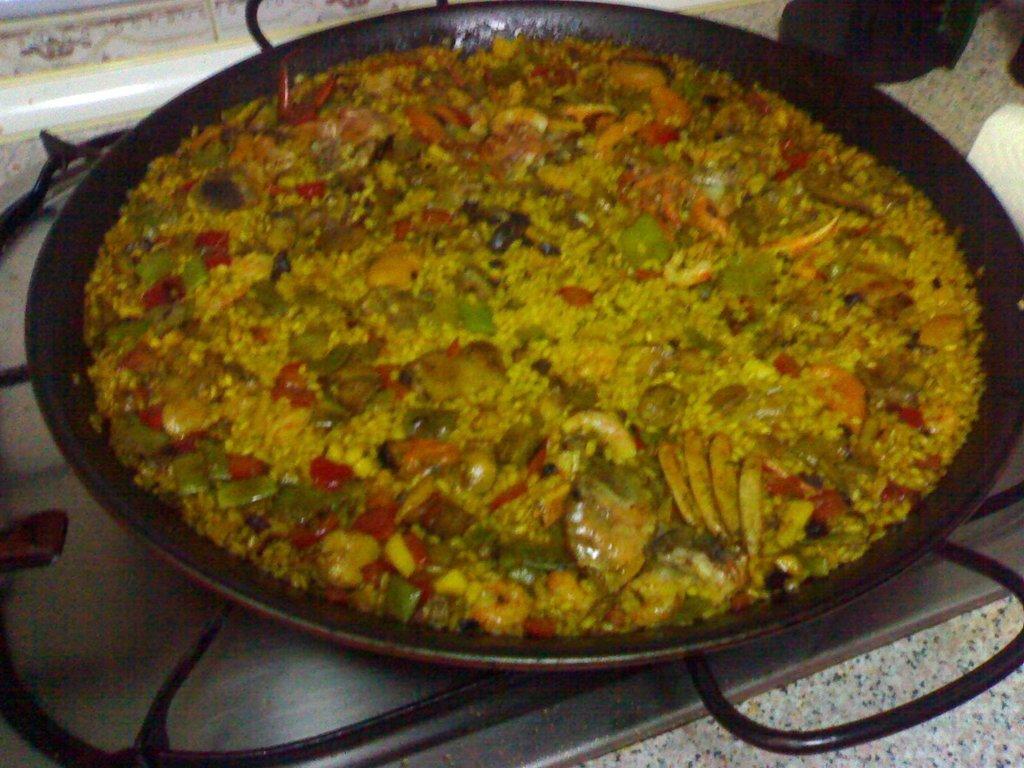Please provide a concise description of this image. In the center of the image we can see a pan containing food placed on the stove. At the bottom there is a countertop. 